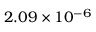Convert formula to latex. <formula><loc_0><loc_0><loc_500><loc_500>2 . 0 9 \times 1 0 ^ { - 6 }</formula> 